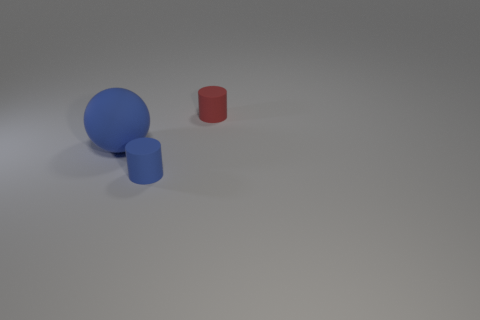Is there a matte block that has the same color as the ball?
Your answer should be very brief. No. There is a cylinder that is in front of the matte thing to the left of the blue rubber thing that is in front of the big blue sphere; what size is it?
Ensure brevity in your answer.  Small. There is a small blue rubber thing; does it have the same shape as the small matte object that is behind the tiny blue matte thing?
Provide a short and direct response. Yes. What number of other things are the same size as the blue matte ball?
Your response must be concise. 0. What is the size of the blue object to the left of the tiny blue cylinder?
Your answer should be very brief. Large. What number of other spheres have the same material as the sphere?
Give a very brief answer. 0. Is the shape of the tiny blue object in front of the blue ball the same as  the small red matte object?
Make the answer very short. Yes. What is the shape of the tiny object that is in front of the tiny red object?
Provide a succinct answer. Cylinder. What material is the large blue object?
Keep it short and to the point. Rubber. There is another rubber cylinder that is the same size as the blue rubber cylinder; what color is it?
Ensure brevity in your answer.  Red. 